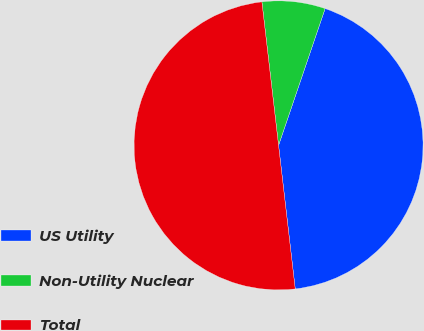<chart> <loc_0><loc_0><loc_500><loc_500><pie_chart><fcel>US Utility<fcel>Non-Utility Nuclear<fcel>Total<nl><fcel>42.94%<fcel>7.06%<fcel>50.0%<nl></chart> 